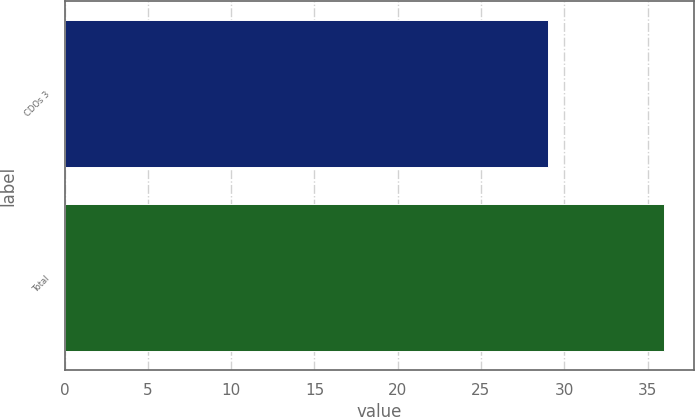Convert chart. <chart><loc_0><loc_0><loc_500><loc_500><bar_chart><fcel>CDOs 3<fcel>Total<nl><fcel>29<fcel>36<nl></chart> 